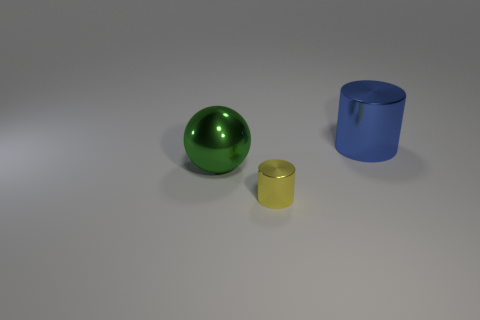What number of other things are there of the same color as the metal sphere?
Provide a short and direct response. 0. Is the number of spheres behind the large cylinder less than the number of small purple shiny objects?
Provide a short and direct response. No. Is there a blue shiny object of the same size as the green object?
Your answer should be very brief. Yes. What number of big cylinders are behind the metal cylinder to the left of the blue shiny thing?
Provide a short and direct response. 1. There is a thing on the left side of the metal cylinder in front of the big blue metal cylinder; what color is it?
Make the answer very short. Green. Is there another tiny metallic object of the same shape as the blue shiny thing?
Offer a very short reply. Yes. There is a large thing that is to the right of the large ball; is it the same shape as the yellow metal object?
Ensure brevity in your answer.  Yes. How many metal things are both on the right side of the big green thing and to the left of the big cylinder?
Keep it short and to the point. 1. There is a big shiny object on the left side of the small yellow shiny cylinder; what is its shape?
Provide a short and direct response. Sphere. What number of tiny yellow cylinders are the same material as the ball?
Ensure brevity in your answer.  1. 